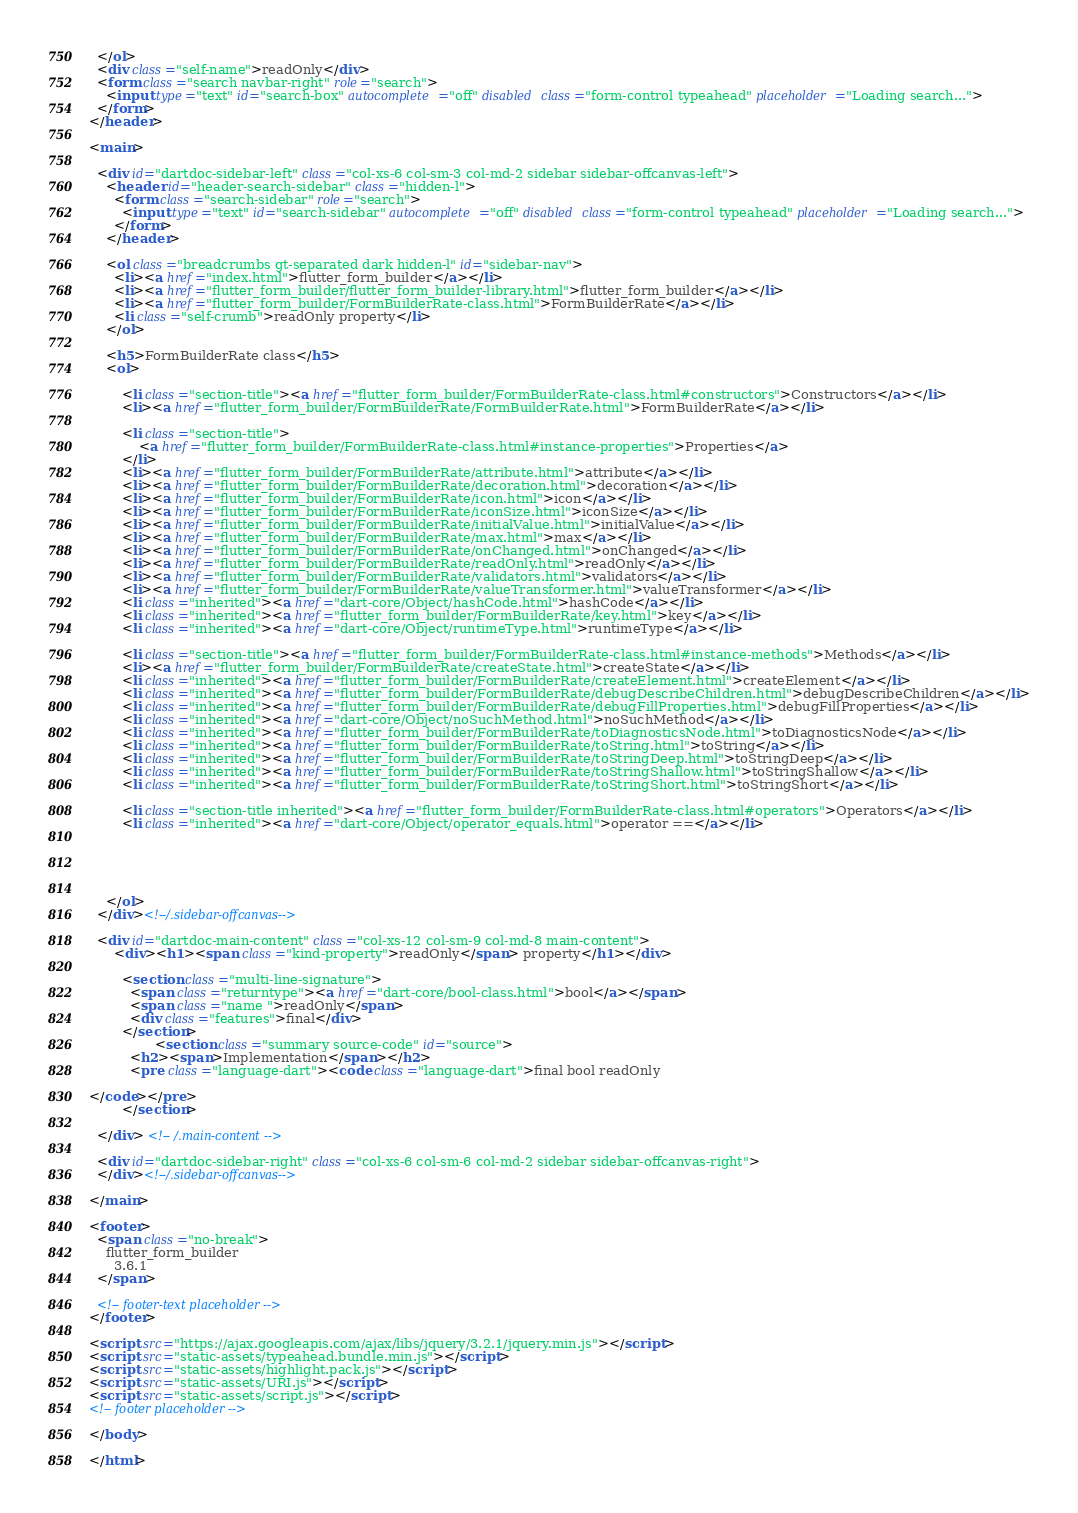Convert code to text. <code><loc_0><loc_0><loc_500><loc_500><_HTML_>  </ol>
  <div class="self-name">readOnly</div>
  <form class="search navbar-right" role="search">
    <input type="text" id="search-box" autocomplete="off" disabled class="form-control typeahead" placeholder="Loading search...">
  </form>
</header>

<main>

  <div id="dartdoc-sidebar-left" class="col-xs-6 col-sm-3 col-md-2 sidebar sidebar-offcanvas-left">
    <header id="header-search-sidebar" class="hidden-l">
      <form class="search-sidebar" role="search">
        <input type="text" id="search-sidebar" autocomplete="off" disabled class="form-control typeahead" placeholder="Loading search...">
      </form>
    </header>
    
    <ol class="breadcrumbs gt-separated dark hidden-l" id="sidebar-nav">
      <li><a href="index.html">flutter_form_builder</a></li>
      <li><a href="flutter_form_builder/flutter_form_builder-library.html">flutter_form_builder</a></li>
      <li><a href="flutter_form_builder/FormBuilderRate-class.html">FormBuilderRate</a></li>
      <li class="self-crumb">readOnly property</li>
    </ol>
    
    <h5>FormBuilderRate class</h5>
    <ol>
    
        <li class="section-title"><a href="flutter_form_builder/FormBuilderRate-class.html#constructors">Constructors</a></li>
        <li><a href="flutter_form_builder/FormBuilderRate/FormBuilderRate.html">FormBuilderRate</a></li>
    
        <li class="section-title">
            <a href="flutter_form_builder/FormBuilderRate-class.html#instance-properties">Properties</a>
        </li>
        <li><a href="flutter_form_builder/FormBuilderRate/attribute.html">attribute</a></li>
        <li><a href="flutter_form_builder/FormBuilderRate/decoration.html">decoration</a></li>
        <li><a href="flutter_form_builder/FormBuilderRate/icon.html">icon</a></li>
        <li><a href="flutter_form_builder/FormBuilderRate/iconSize.html">iconSize</a></li>
        <li><a href="flutter_form_builder/FormBuilderRate/initialValue.html">initialValue</a></li>
        <li><a href="flutter_form_builder/FormBuilderRate/max.html">max</a></li>
        <li><a href="flutter_form_builder/FormBuilderRate/onChanged.html">onChanged</a></li>
        <li><a href="flutter_form_builder/FormBuilderRate/readOnly.html">readOnly</a></li>
        <li><a href="flutter_form_builder/FormBuilderRate/validators.html">validators</a></li>
        <li><a href="flutter_form_builder/FormBuilderRate/valueTransformer.html">valueTransformer</a></li>
        <li class="inherited"><a href="dart-core/Object/hashCode.html">hashCode</a></li>
        <li class="inherited"><a href="flutter_form_builder/FormBuilderRate/key.html">key</a></li>
        <li class="inherited"><a href="dart-core/Object/runtimeType.html">runtimeType</a></li>
    
        <li class="section-title"><a href="flutter_form_builder/FormBuilderRate-class.html#instance-methods">Methods</a></li>
        <li><a href="flutter_form_builder/FormBuilderRate/createState.html">createState</a></li>
        <li class="inherited"><a href="flutter_form_builder/FormBuilderRate/createElement.html">createElement</a></li>
        <li class="inherited"><a href="flutter_form_builder/FormBuilderRate/debugDescribeChildren.html">debugDescribeChildren</a></li>
        <li class="inherited"><a href="flutter_form_builder/FormBuilderRate/debugFillProperties.html">debugFillProperties</a></li>
        <li class="inherited"><a href="dart-core/Object/noSuchMethod.html">noSuchMethod</a></li>
        <li class="inherited"><a href="flutter_form_builder/FormBuilderRate/toDiagnosticsNode.html">toDiagnosticsNode</a></li>
        <li class="inherited"><a href="flutter_form_builder/FormBuilderRate/toString.html">toString</a></li>
        <li class="inherited"><a href="flutter_form_builder/FormBuilderRate/toStringDeep.html">toStringDeep</a></li>
        <li class="inherited"><a href="flutter_form_builder/FormBuilderRate/toStringShallow.html">toStringShallow</a></li>
        <li class="inherited"><a href="flutter_form_builder/FormBuilderRate/toStringShort.html">toStringShort</a></li>
    
        <li class="section-title inherited"><a href="flutter_form_builder/FormBuilderRate-class.html#operators">Operators</a></li>
        <li class="inherited"><a href="dart-core/Object/operator_equals.html">operator ==</a></li>
    
    
    
    
    
    </ol>
  </div><!--/.sidebar-offcanvas-->

  <div id="dartdoc-main-content" class="col-xs-12 col-sm-9 col-md-8 main-content">
      <div><h1><span class="kind-property">readOnly</span> property</h1></div>

        <section class="multi-line-signature">
          <span class="returntype"><a href="dart-core/bool-class.html">bool</a></span>
          <span class="name ">readOnly</span>
          <div class="features">final</div>
        </section>
                <section class="summary source-code" id="source">
          <h2><span>Implementation</span></h2>
          <pre class="language-dart"><code class="language-dart">final bool readOnly

</code></pre>
        </section>

  </div> <!-- /.main-content -->

  <div id="dartdoc-sidebar-right" class="col-xs-6 col-sm-6 col-md-2 sidebar sidebar-offcanvas-right">
  </div><!--/.sidebar-offcanvas-->

</main>

<footer>
  <span class="no-break">
    flutter_form_builder
      3.6.1
  </span>

  <!-- footer-text placeholder -->
</footer>

<script src="https://ajax.googleapis.com/ajax/libs/jquery/3.2.1/jquery.min.js"></script>
<script src="static-assets/typeahead.bundle.min.js"></script>
<script src="static-assets/highlight.pack.js"></script>
<script src="static-assets/URI.js"></script>
<script src="static-assets/script.js"></script>
<!-- footer placeholder -->

</body>

</html>
</code> 